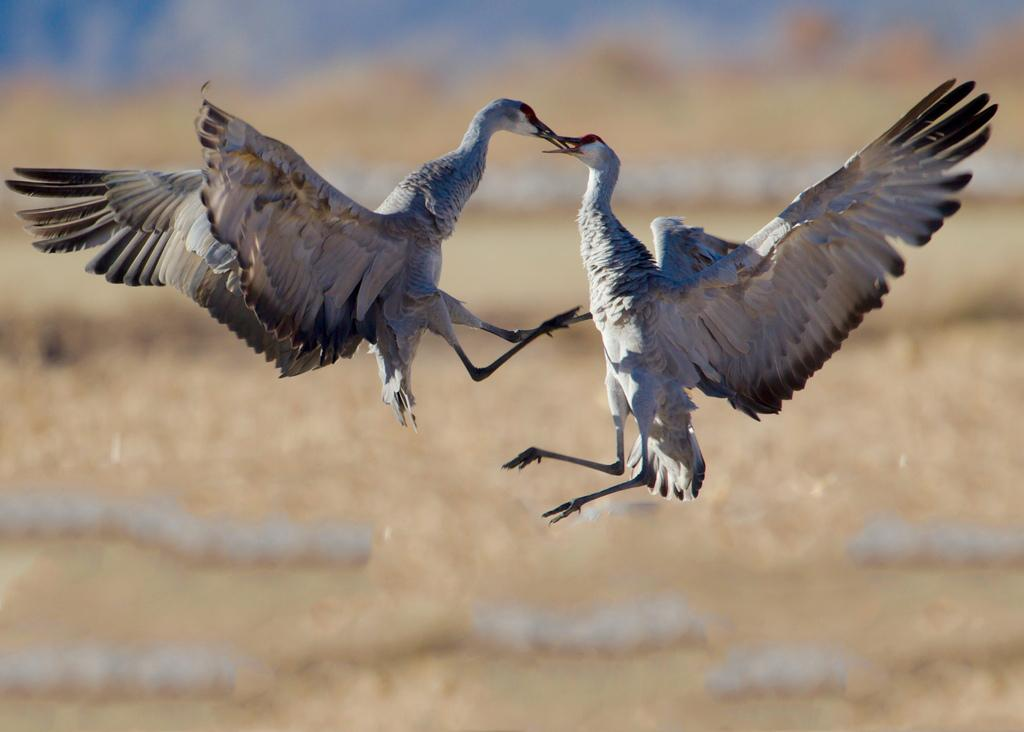What animals are present in the image? There are two birds in the image. Where are the birds located in the image? The birds are in the center of the image. What type of lead can be seen being used by the birds in the image? There is no lead present in the image, and the birds are not using any lead. What type of land can be seen in the image? The image does not show any land; it only features two birds. 